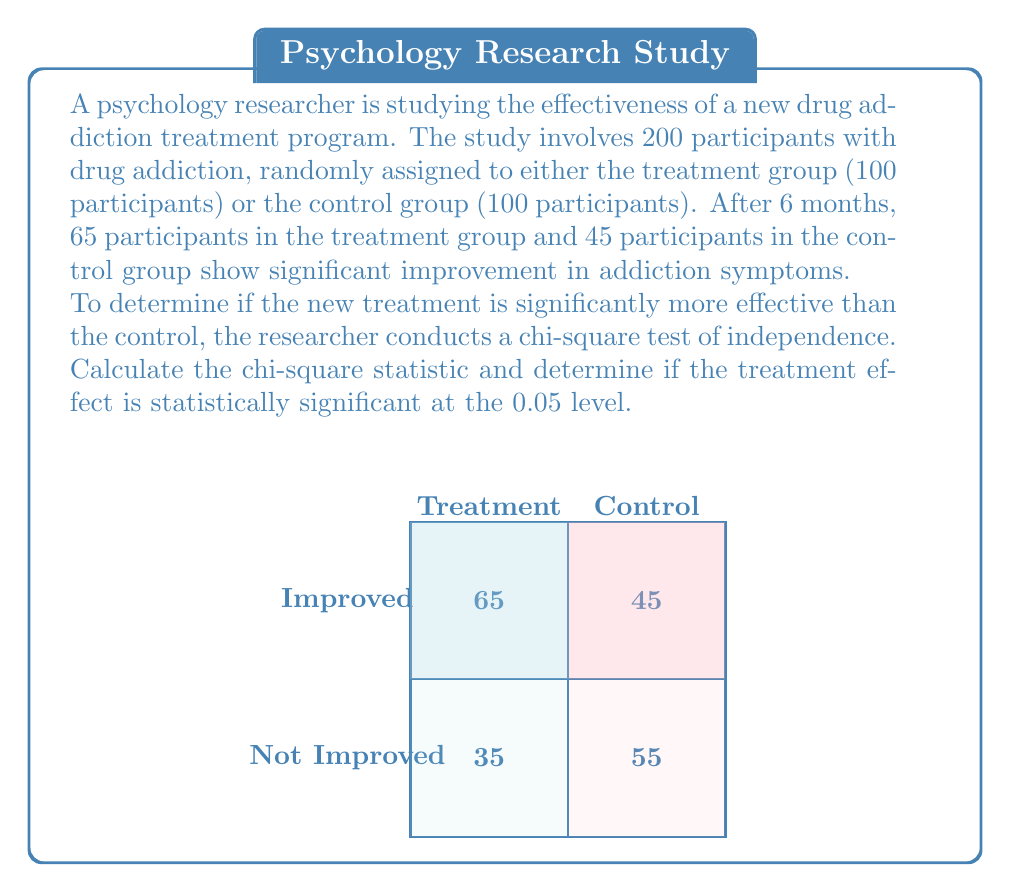Show me your answer to this math problem. Let's approach this step-by-step:

1) First, we need to set up our contingency table:

   | Treatment | Control | Total
---|-----------|---------|------
Improved | 65 | 45 | 110
Not Improved | 35 | 55 | 90
Total | 100 | 100 | 200

2) The formula for the chi-square statistic is:

   $$ \chi^2 = \sum \frac{(O - E)^2}{E} $$

   where O is the observed frequency and E is the expected frequency.

3) We need to calculate the expected frequencies for each cell:

   $E = \frac{\text{row total} \times \text{column total}}{\text{grand total}}$

   For "Improved" in Treatment group: $E = \frac{110 \times 100}{200} = 55$
   For "Not Improved" in Treatment group: $E = \frac{90 \times 100}{200} = 45$
   For "Improved" in Control group: $E = \frac{110 \times 100}{200} = 55$
   For "Not Improved" in Control group: $E = \frac{90 \times 100}{200} = 45$

4) Now we can calculate the chi-square statistic:

   $$ \chi^2 = \frac{(65-55)^2}{55} + \frac{(35-45)^2}{45} + \frac{(45-55)^2}{55} + \frac{(55-45)^2}{45} $$
   $$ = \frac{100}{55} + \frac{100}{45} + \frac{100}{55} + \frac{100}{45} $$
   $$ = 1.82 + 2.22 + 1.82 + 2.22 $$
   $$ = 8.08 $$

5) The degrees of freedom (df) for a 2x2 table is (rows-1)(columns-1) = 1

6) The critical value for chi-square with df=1 at α=0.05 is 3.841

7) Since our calculated chi-square (8.08) is greater than the critical value (3.841), we reject the null hypothesis.

Therefore, the treatment effect is statistically significant at the 0.05 level.
Answer: $\chi^2 = 8.08$, significant at $p < 0.05$ 